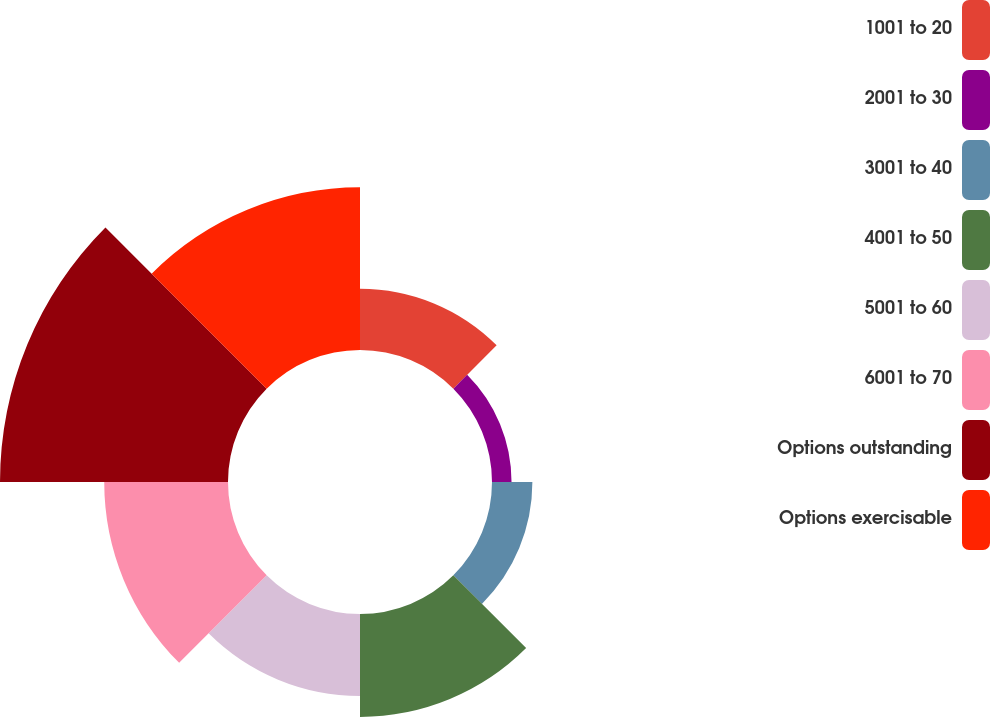Convert chart. <chart><loc_0><loc_0><loc_500><loc_500><pie_chart><fcel>1001 to 20<fcel>2001 to 30<fcel>3001 to 40<fcel>4001 to 50<fcel>5001 to 60<fcel>6001 to 70<fcel>Options outstanding<fcel>Options exercisable<nl><fcel>7.46%<fcel>2.38%<fcel>4.92%<fcel>12.54%<fcel>10.0%<fcel>15.08%<fcel>27.78%<fcel>19.82%<nl></chart> 